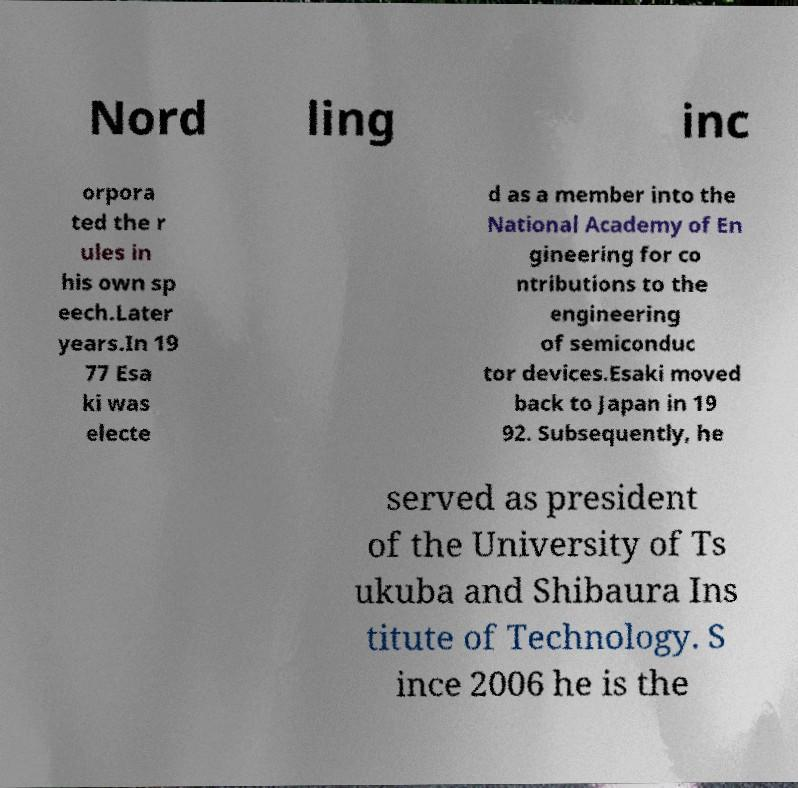Can you accurately transcribe the text from the provided image for me? Nord ling inc orpora ted the r ules in his own sp eech.Later years.In 19 77 Esa ki was electe d as a member into the National Academy of En gineering for co ntributions to the engineering of semiconduc tor devices.Esaki moved back to Japan in 19 92. Subsequently, he served as president of the University of Ts ukuba and Shibaura Ins titute of Technology. S ince 2006 he is the 